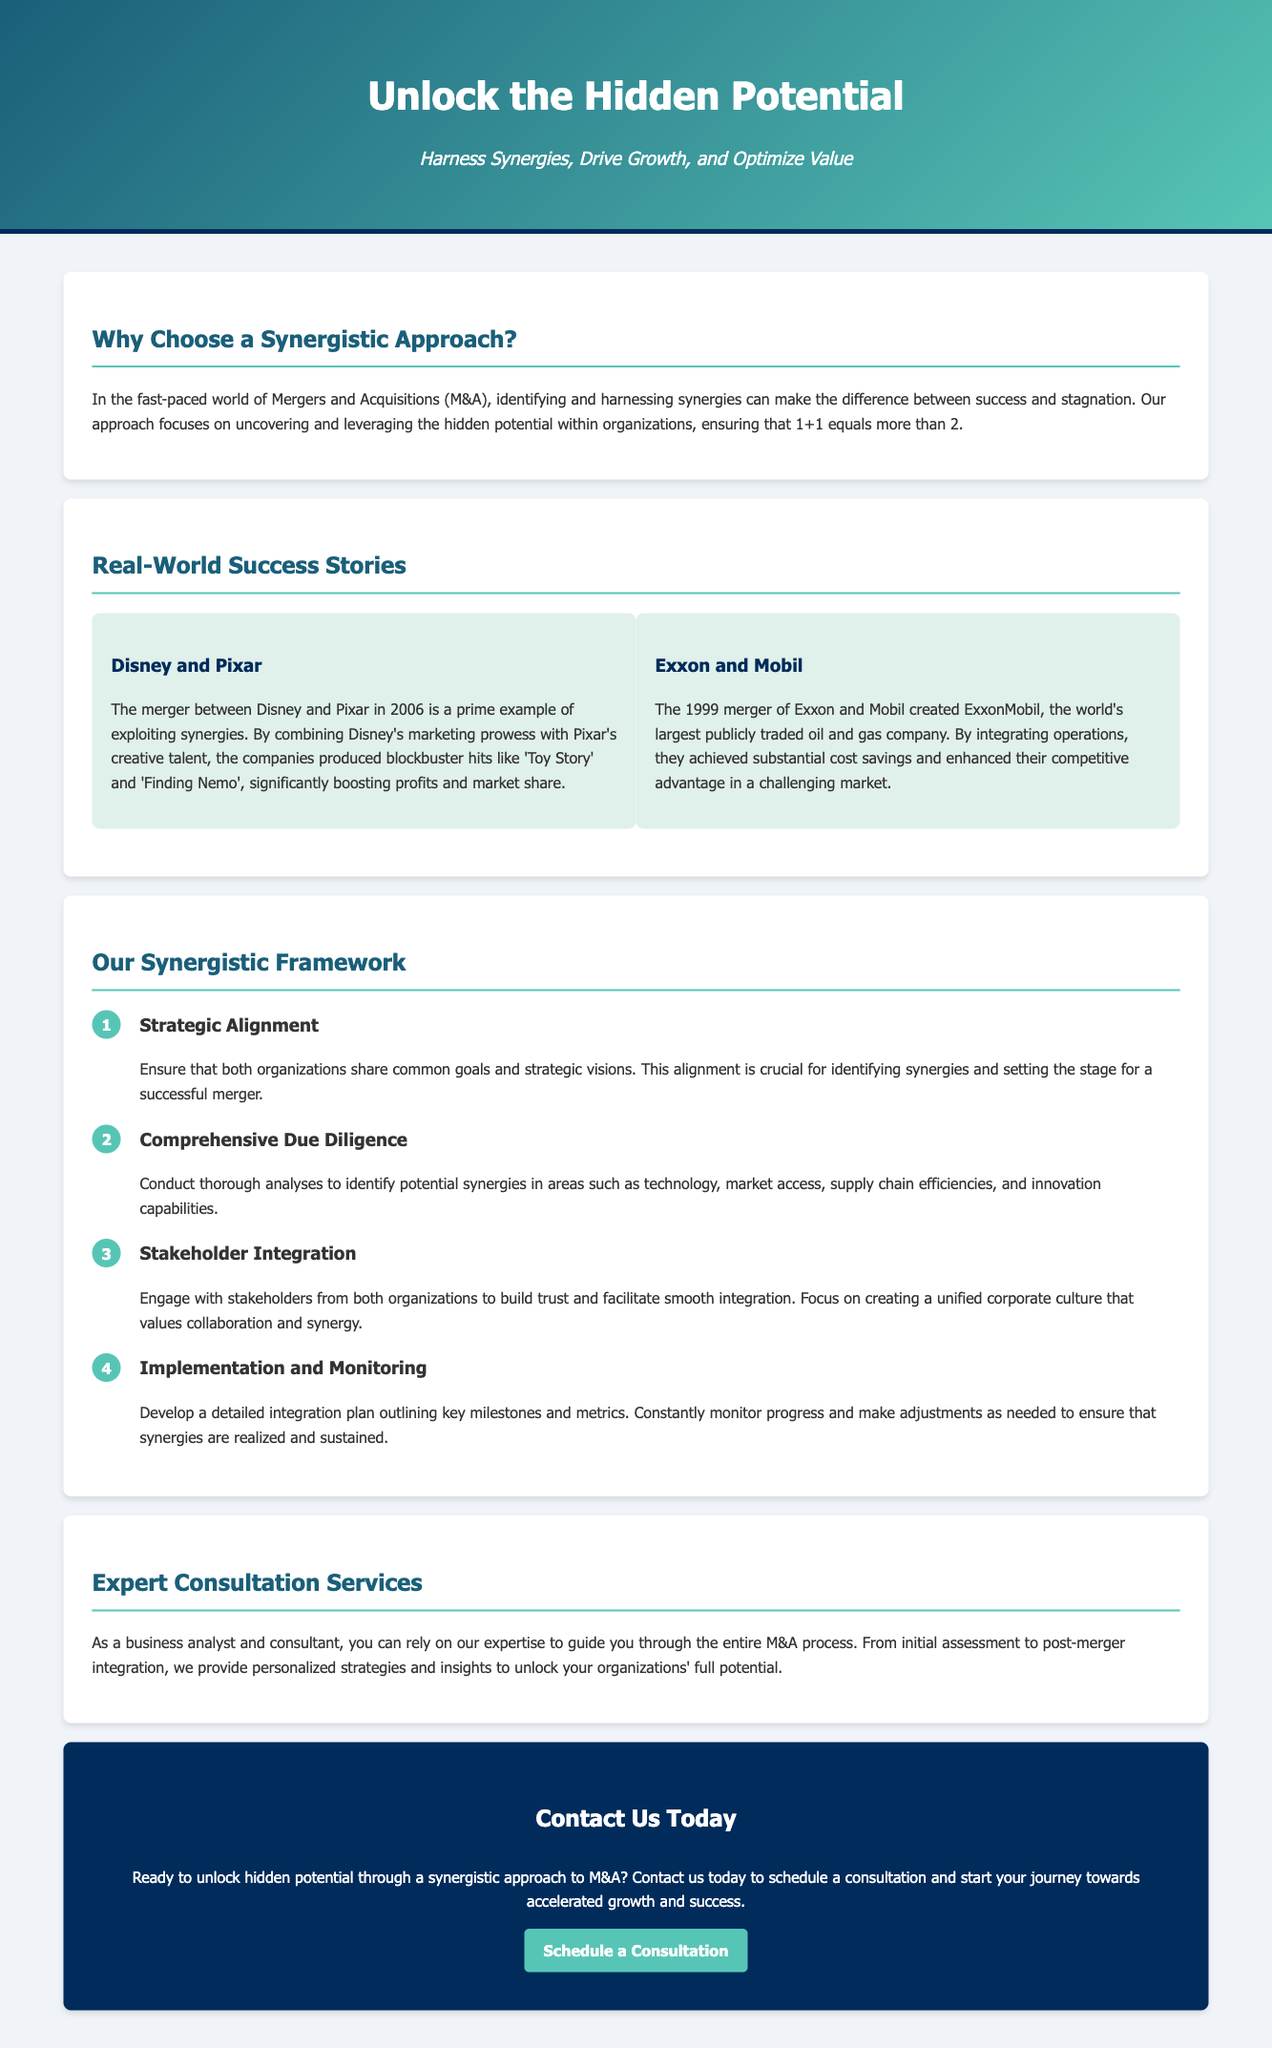what is the title of the document? The title is prominently displayed at the top of the document to identify its subject matter.
Answer: Unlock the Hidden Potential: A Synergistic Approach to M&A what is the tagline of the document? The tagline succinctly summarizes the purpose of the document and is located under the title.
Answer: Harness Synergies, Drive Growth, and Optimize Value which two companies are highlighted in the success stories? These companies serve as examples of successful synergies in M&A, showing how their mergers benefitted them.
Answer: Disney and Pixar, Exxon and Mobil how many steps are in the synergistic framework? The steps outline the approach taken in the M&A process and are listed in the framework section.
Answer: Four what is the first step in the synergistic framework? This step is crucial to ensure common objectives between merging organizations.
Answer: Strategic Alignment what service does the document promote? This service assists organizations during M&A processes to maximize synergies and growth potential.
Answer: Expert Consultation Services what does the call-to-action section encourage readers to do? This section aims to engage readers by prompting them to take a specific action.
Answer: Schedule a Consultation what year did the merger between Exxon and Mobil take place? This information is provided as part of the description of their success story within the document.
Answer: 1999 what are the main areas of focus during the comprehensive due diligence step? These areas identify potential improvements during the merger process and are pointed out in the framework.
Answer: Technology, market access, supply chain efficiencies, and innovation capabilities 